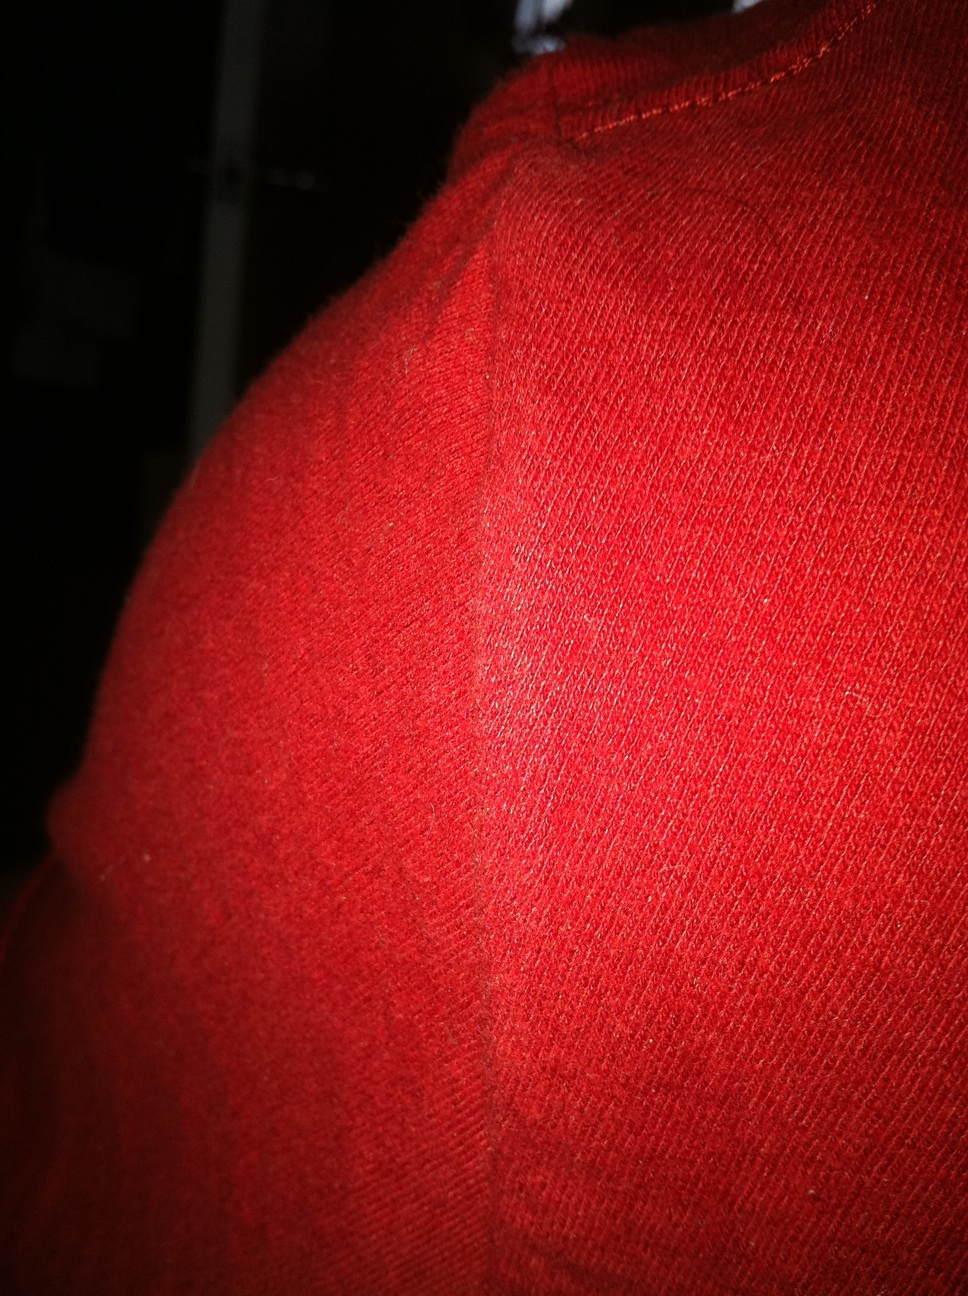If this fabric could narrate a story, what would it say? This fabric would tell a tale of warmth wrapped in a vibrant hue, narrating its journey from the loom to the wardrobes of wanderers. It would recount how it embraced winters, shielding many from the cold while adding a splash of color to muted days. From bustling city streets to serene countryside paths, every thread has a story embedded in its texture, intertwined with adventures, laughter, and the embrace of loved ones. What creative project could one envision using this red fabric? One could envision creating a themed collection of accessories using this red fabric. Start with cozy beanies and scarves for a winter set. Expand to include mittens and ear warmers, adding unique embellishments like handcrafted wooden buttons or embroidered designs. The collection could even extend to home decor, with red knitted pillow covers and throws to add a touch of warmth and festival charm to living spaces. Each piece would not only provide comfort but also tell a story of craftsmanship and creativity. 